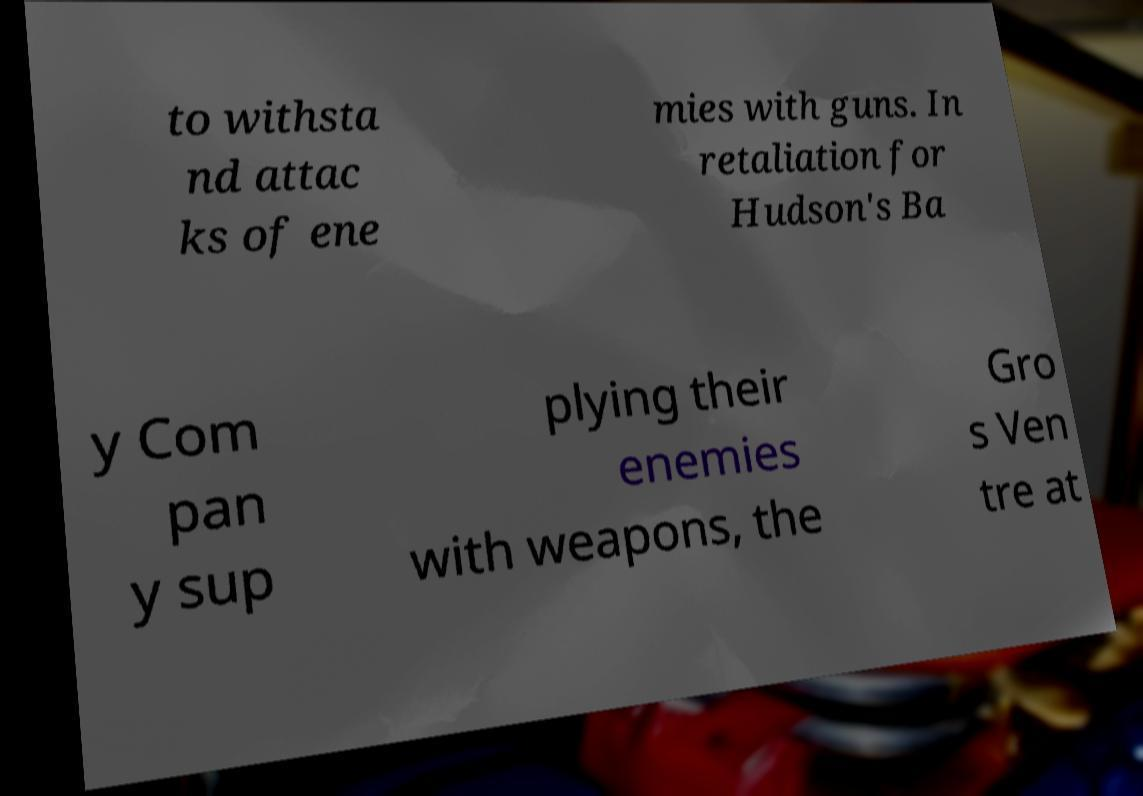Can you accurately transcribe the text from the provided image for me? to withsta nd attac ks of ene mies with guns. In retaliation for Hudson's Ba y Com pan y sup plying their enemies with weapons, the Gro s Ven tre at 